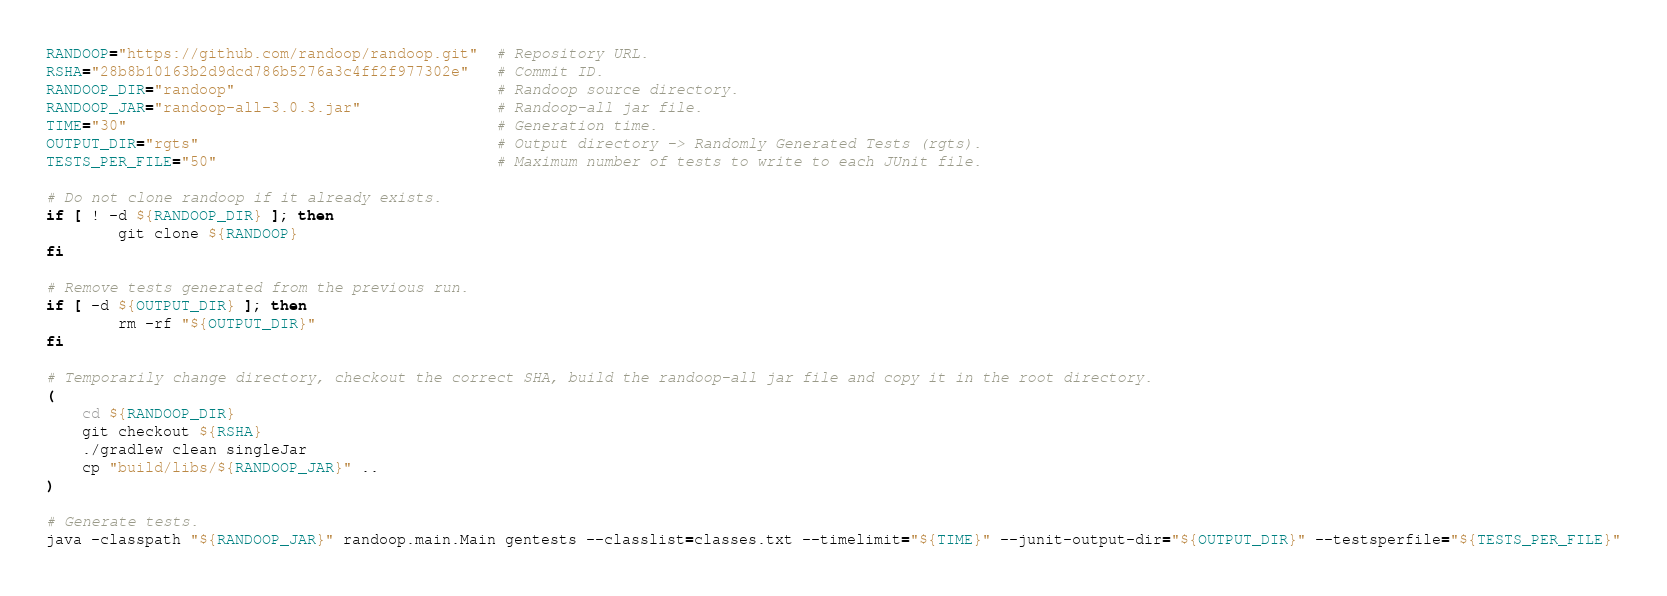<code> <loc_0><loc_0><loc_500><loc_500><_Bash_>RANDOOP="https://github.com/randoop/randoop.git"  # Repository URL.
RSHA="28b8b10163b2d9dcd786b5276a3c4ff2f977302e"   # Commit ID.
RANDOOP_DIR="randoop"                             # Randoop source directory.
RANDOOP_JAR="randoop-all-3.0.3.jar"               # Randoop-all jar file.
TIME="30"                                         # Generation time.
OUTPUT_DIR="rgts"                                 # Output directory -> Randomly Generated Tests (rgts).
TESTS_PER_FILE="50"                               # Maximum number of tests to write to each JUnit file.

# Do not clone randoop if it already exists.
if [ ! -d ${RANDOOP_DIR} ]; then
        git clone ${RANDOOP}
fi

# Remove tests generated from the previous run.
if [ -d ${OUTPUT_DIR} ]; then
        rm -rf "${OUTPUT_DIR}"
fi

# Temporarily change directory, checkout the correct SHA, build the randoop-all jar file and copy it in the root directory.
(
	cd ${RANDOOP_DIR}
	git checkout ${RSHA}
	./gradlew clean singleJar
	cp "build/libs/${RANDOOP_JAR}" ..
)

# Generate tests.
java -classpath "${RANDOOP_JAR}" randoop.main.Main gentests --classlist=classes.txt --timelimit="${TIME}" --junit-output-dir="${OUTPUT_DIR}" --testsperfile="${TESTS_PER_FILE}"</code> 